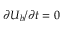Convert formula to latex. <formula><loc_0><loc_0><loc_500><loc_500>{ \partial U _ { b } } / { \partial t } = 0</formula> 